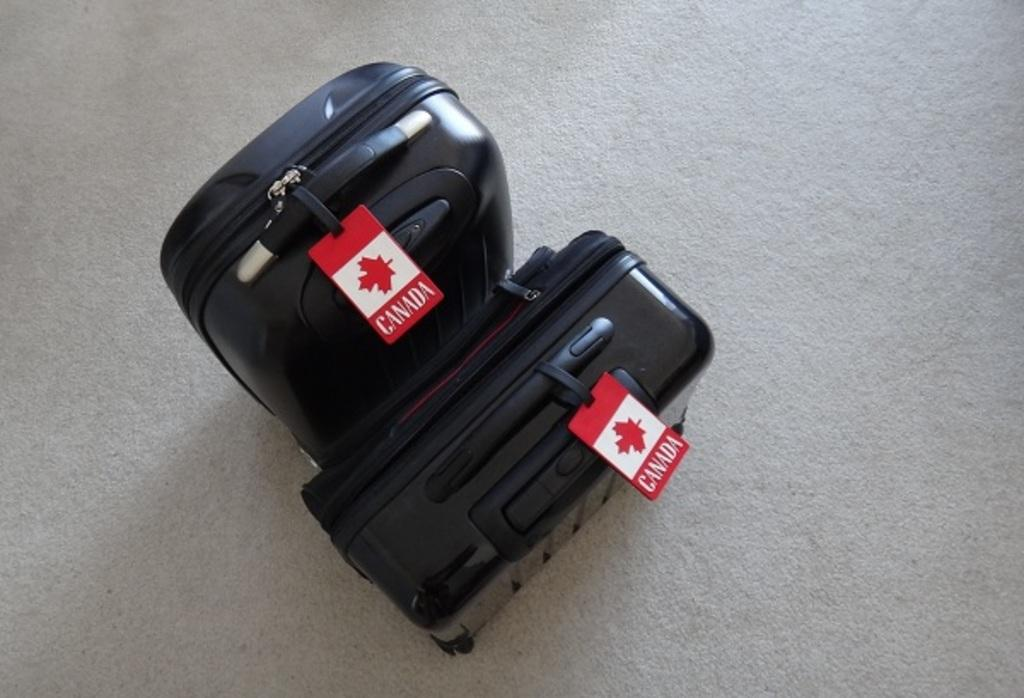How many bags are visible in the image? There are two bags in the image. Where are the bags located? The bags are on the ground. What is the color of the bags? The bags are black in color. Are there any coal pieces visible in the image? No, there are no coal pieces present in the image. Can you see any jellyfish floating in the bags? No, there are no jellyfish present in the image. 